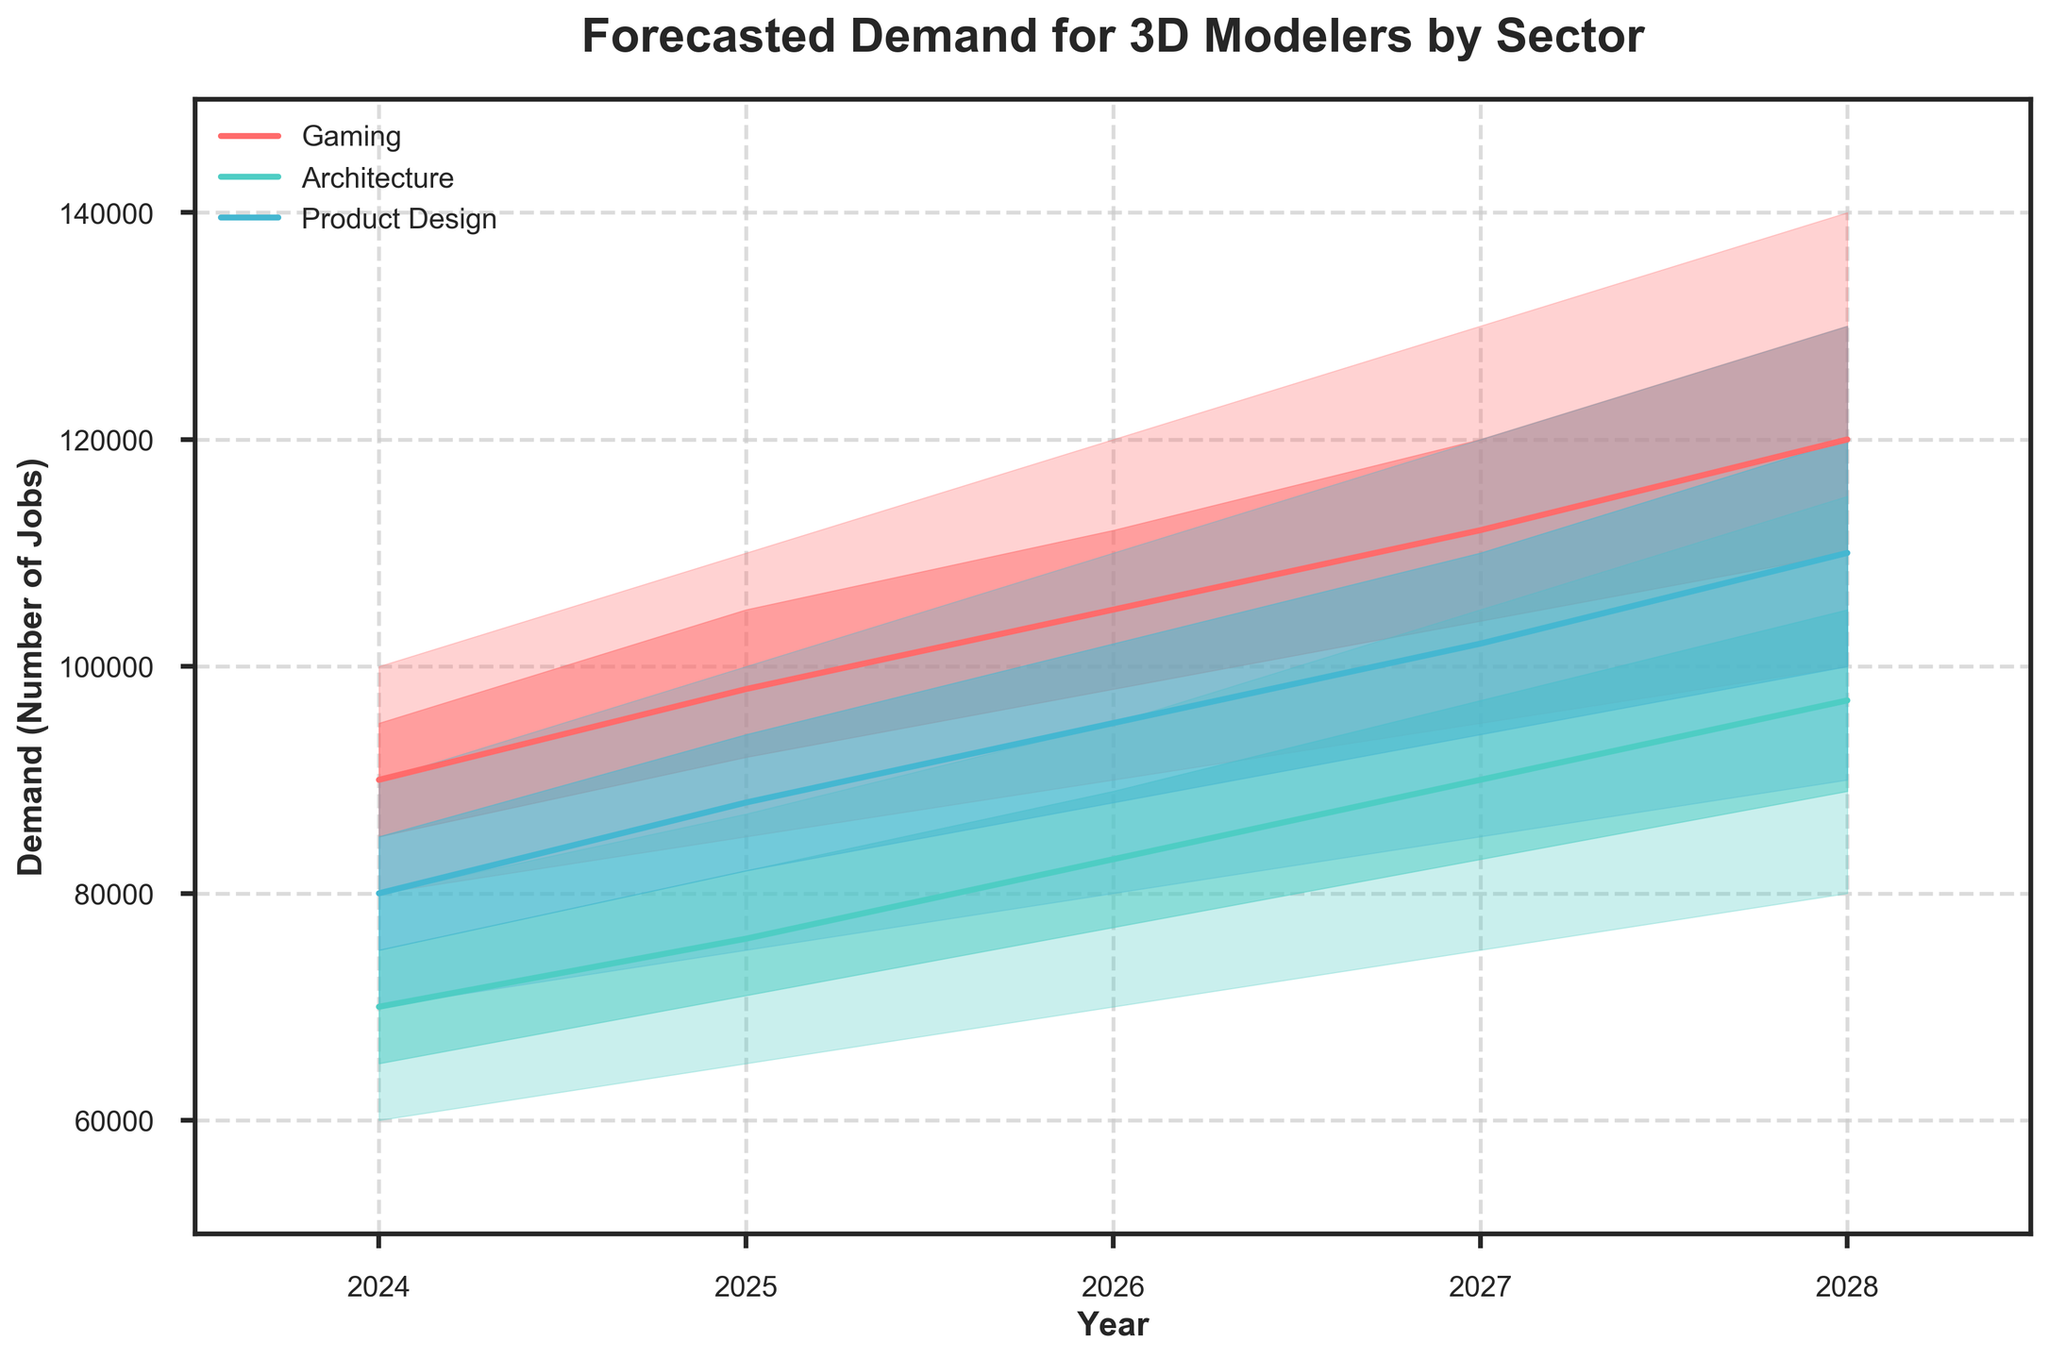What does the fan chart represent? The fan chart's title, "Forecasted Demand for 3D Modelers by Sector," indicates that it represents the predicted number of jobs for 3D modelers in three sectors: Gaming, Architecture, and Product Design.
Answer: Forecasted job demand for 3D modelers in Gaming, Architecture, and Product Design What is the forecasted demand in the Gaming sector for the year 2026 in the Mid scenario? In the Gaming sector, the Mid scenario for the year 2026 is shown directly by the solid line representing the median values.
Answer: 105,000 Which sector has the highest predicted job demand in 2028 in the High scenario? By looking at the highest value in the shaded regions for the year 2028, we can see which predicted sector is highest.
Answer: Gaming How does the forecasted Mid scenario for Product Design change from 2025 to 2028? Compare the Mid (median) values of the Product Design sector between 2025 and 2028. For 2025, it's 88,000. For 2028, it's 110,000.
Answer: Increases by 22,000 Which sector shows the largest increase in the High scenario from 2024 to 2028? Compare the High scenario values between 2024 and 2028 for each sector.
Answer: Gaming What is the average forecasted HighMid demand for Architecture over the years 2024 to 2028? Sum the HighMid values for Architecture from 2024 (75,000), 2025 (82,000), 2026 (89,000), 2027 (97,000), and 2028 (105,000) and then divide by the number of years. (75,000 + 82,000 + 89,000 + 97,000 + 105,000) / 5
Answer: 89,600 How much higher is the High forecast for Gaming in 2027 compared to Architecture in the same year? Subtract the High forecast value for Architecture in 2027 (105,000) from the High forecast value for Gaming in 2027 (130,000).
Answer: 25,000 What color represents the Product Design sector, and what does this signify in the chart? Observing the color legend, the Product Design sector is represented by a specific color. This signifies all the forecasted demand ranges for this sector in the plot.
Answer: A specific color (e.g., #45B7D1) Which sector shows the smallest range of forecasted demand in 2025 according to the Low and High scenarios? Compare the differences between Low and High scenarios for each sector in 2025: Gaming (110,000 - 85,000 = 25,000), Architecture (87,000 - 65,000 = 22,000), Product Design (100,000 - 75,000 = 25,000).
Answer: Architecture 